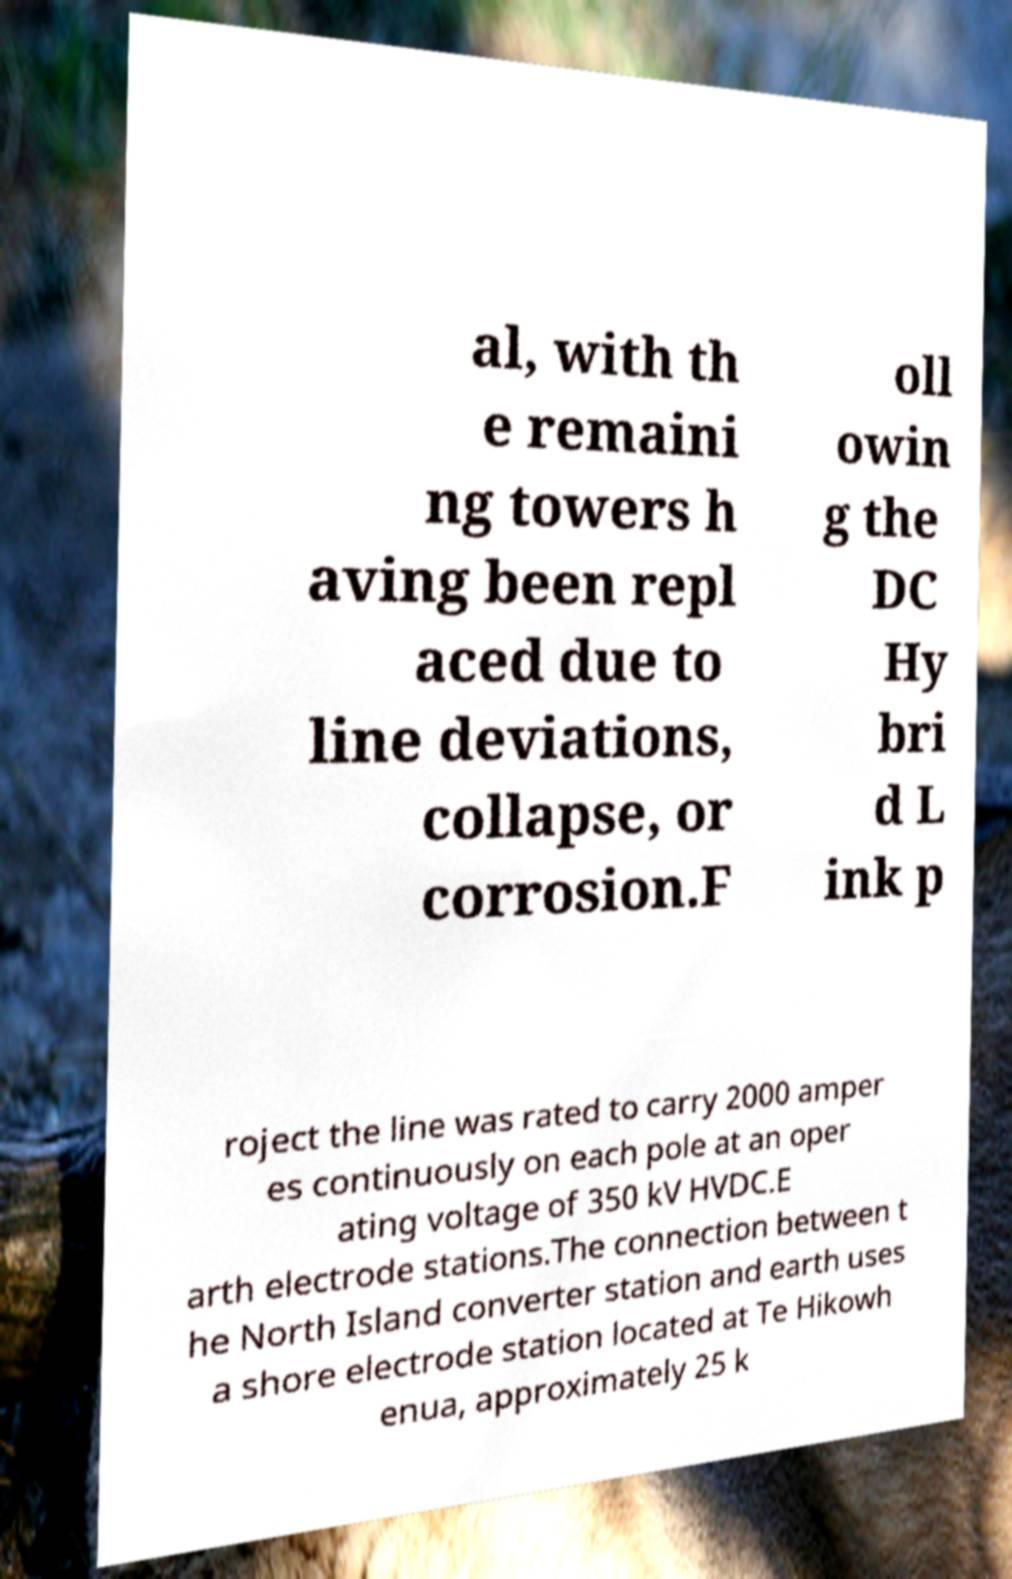Please read and relay the text visible in this image. What does it say? al, with th e remaini ng towers h aving been repl aced due to line deviations, collapse, or corrosion.F oll owin g the DC Hy bri d L ink p roject the line was rated to carry 2000 amper es continuously on each pole at an oper ating voltage of 350 kV HVDC.E arth electrode stations.The connection between t he North Island converter station and earth uses a shore electrode station located at Te Hikowh enua, approximately 25 k 